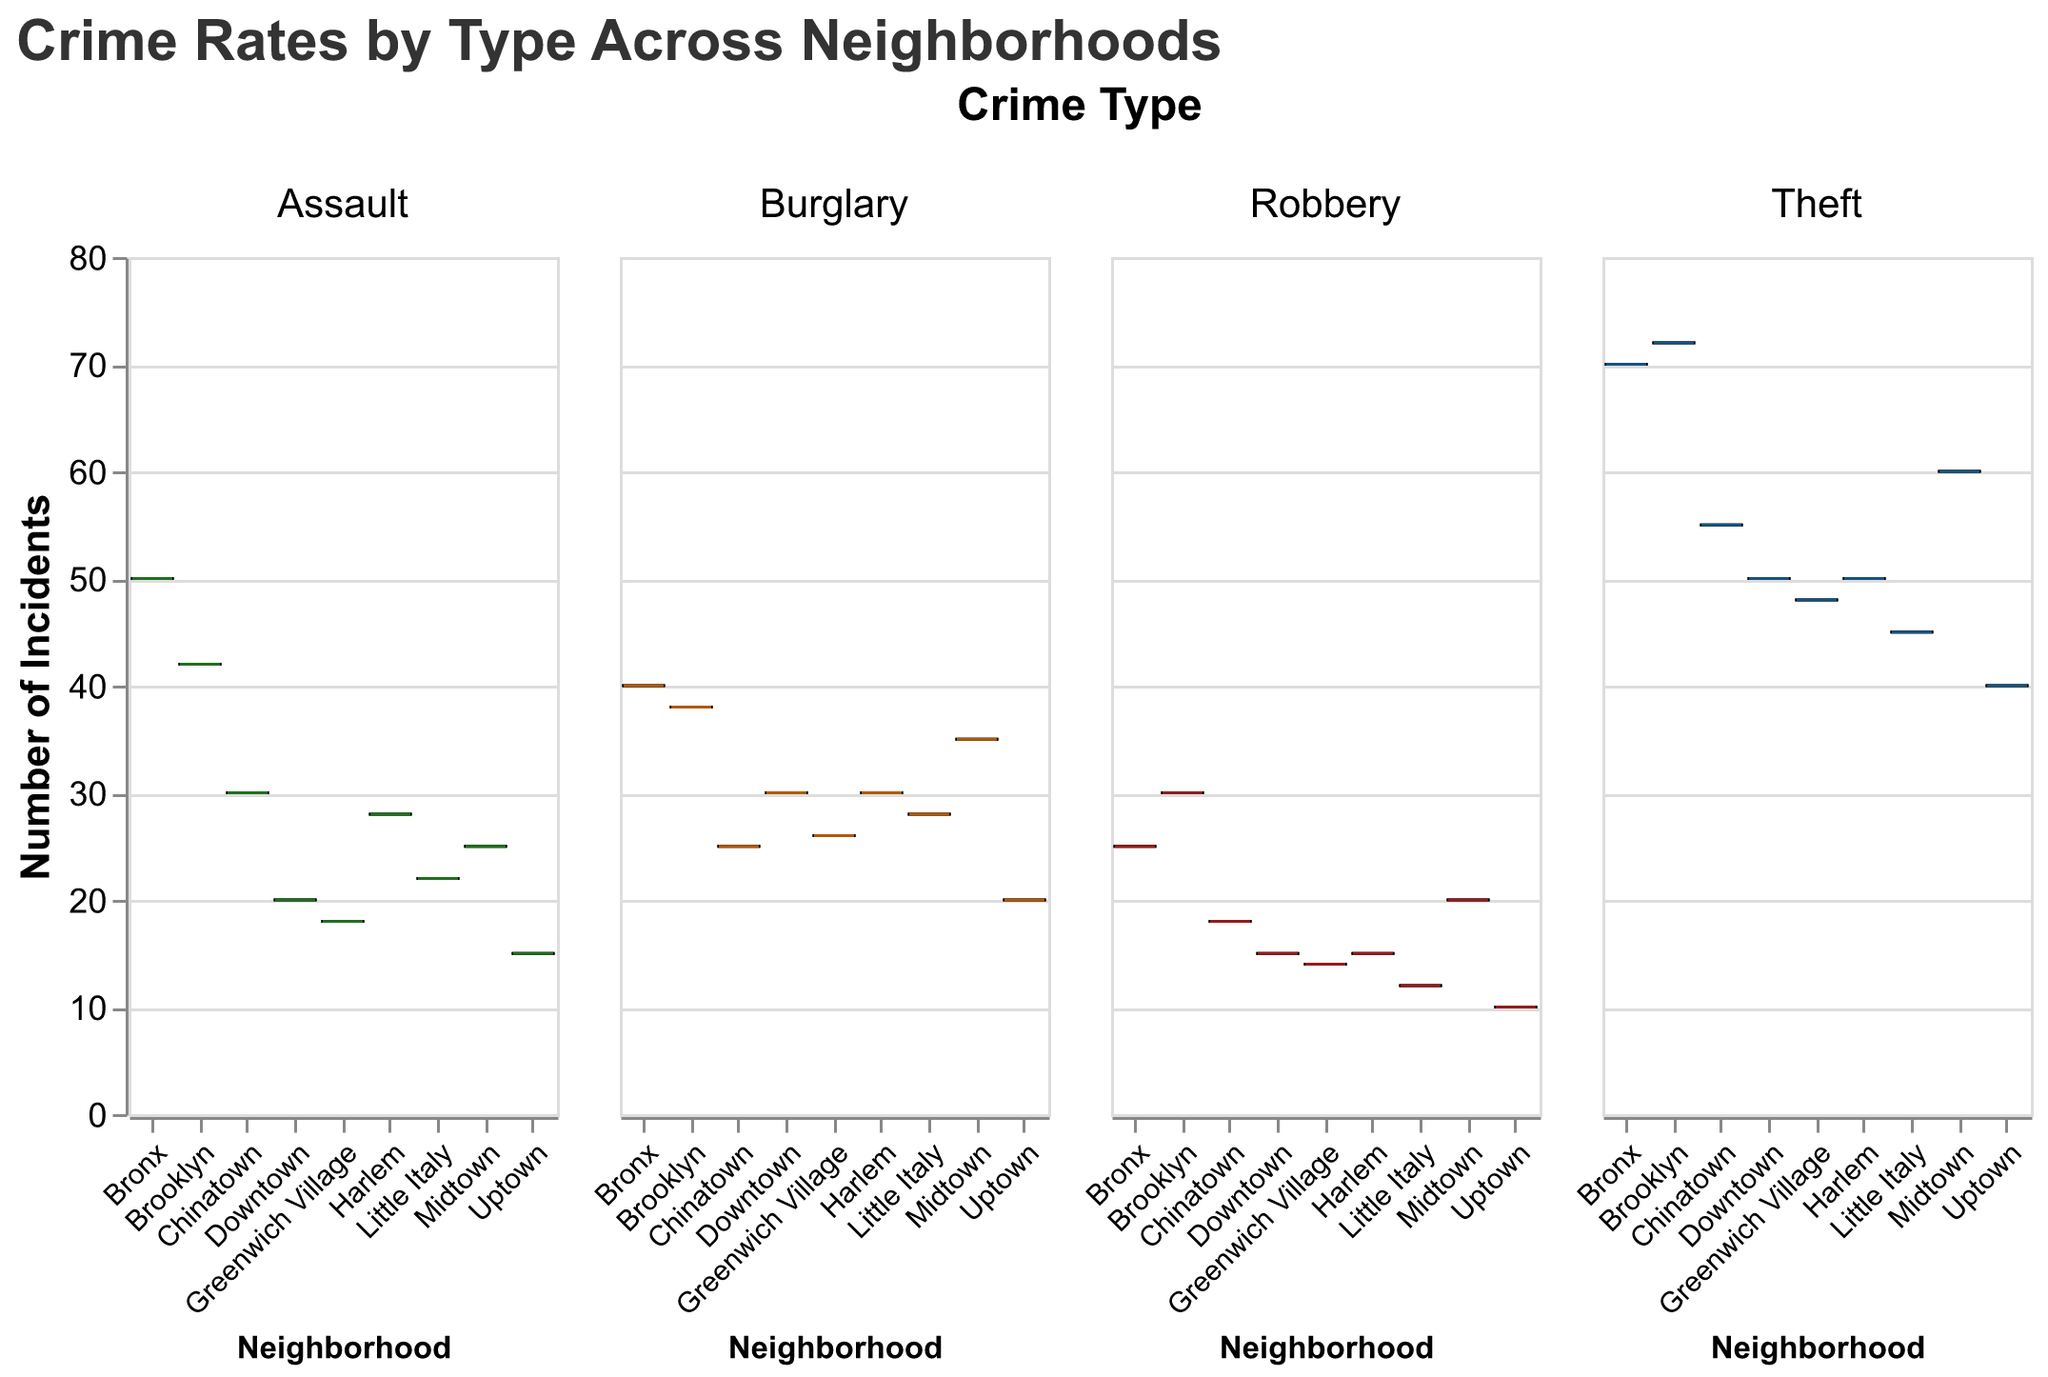What's the highest number of Theft incidents in a neighborhood? Look at the max value for the Theft box plot across all neighborhoods. Brooklyn has the highest value at 72.
Answer: 72 Which neighborhood has the lowest number of Assault incidents? Examine the box plots for Assault incidents across all neighborhoods. Uptown has the lowest value at 15.
Answer: Uptown What is the median number of Burglary incidents in Midtown? In the Burglary box plot for Midtown, the median line is observed. The median is 35.
Answer: 35 Are there more incidents of Theft or Robbery in Chinatown? Compare the incidents in the Theft and Robbery box plots for Chinatown. Theft (55 incidents) is greater than Robbery (18 incidents).
Answer: Theft Which crime type has the most variability in incident numbers across neighborhoods? Assess the range in the box plots for each crime type. Assault shows a range from 15 to 50, indicating high variability.
Answer: Assault What's the difference between the highest number of Assault incidents and the highest number of Robbery incidents across all neighborhoods? Highest value in Assault (Bronx at 50) minus highest value in Robbery (Brooklyn at 30) equals 20.
Answer: 20 In which neighborhoods are the median incidents of Theft higher than 50? Examine Theft median lines and compare to 50. Brooklyn (72), Bronx (70), Midtown (60), and Harlem (50) have medians higher than 50.
Answer: Brooklyn, Bronx, Midtown How does the median number of Burglary incidents in Uptown compare to that in the Bronx? Median Burglary incidents in Uptown (20) and Bronx (40) are compared. Bronx has more.
Answer: Bronx Are there any neighborhoods where the robbery incidents are consistently low (no outliers above 20 incidents)? Look for Robbery box plots with no values above 20. Uptown and Little Italy fit this criterion.
Answer: Uptown, Little Italy Which neighborhood shows the highest number of Assault incidents, and what is this value? Locate the box plot for Assault and find the highest number. Bronx has the highest value at 50.
Answer: Bronx, 50 